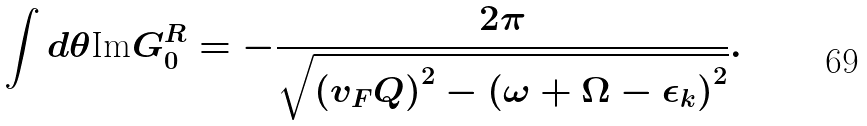<formula> <loc_0><loc_0><loc_500><loc_500>\int d \theta \text {Im} G _ { 0 } ^ { R } = - \frac { 2 \pi } { \sqrt { \left ( v _ { F } Q \right ) ^ { 2 } - \left ( \omega + \Omega - \epsilon _ { k } \right ) ^ { 2 } } } .</formula> 